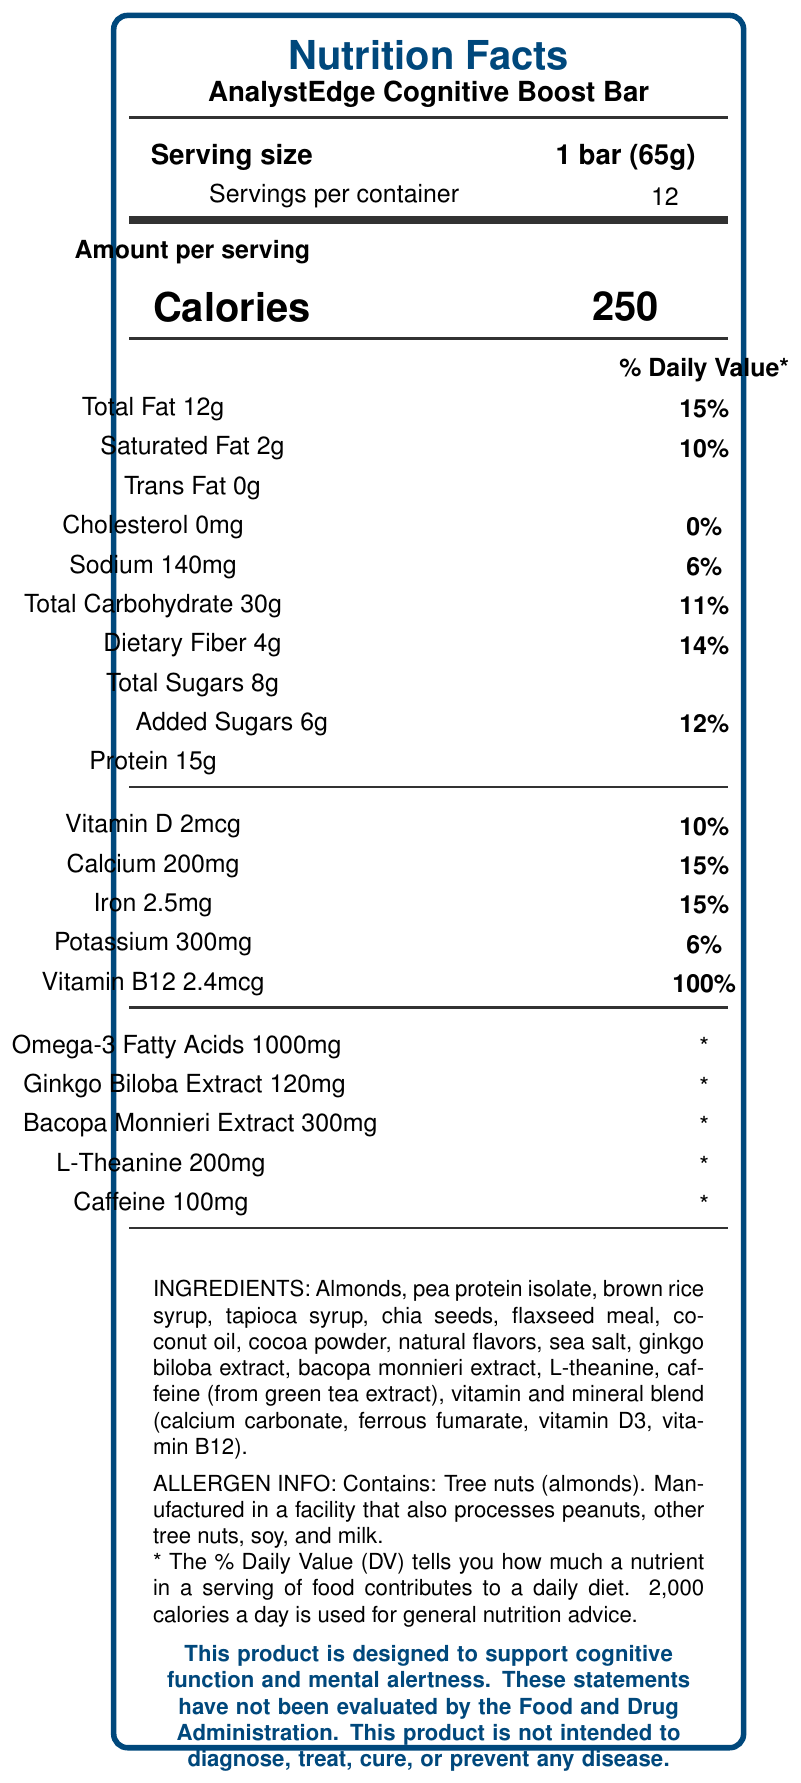What is the serving size of the AnalystEdge Cognitive Boost Bar? The serving size is mentioned directly under the "Serving size" section as 1 bar weighing 65 grams.
Answer: 1 bar (65g) How many servings are there per container? The number of servings per container is listed right under the "Serving size" and next to the label "Servings per container."
Answer: 12 How many calories are in one serving of the AnalystEdge Cognitive Boost Bar? Calories per serving are listed prominently in the middle of the label, indicating 250 calories per bar.
Answer: 250 What are the total carbohydrates in one bar? The total carbohydrate content is listed in the nutrition facts section, under the macronutrients breakdown, as 30 grams.
Answer: 30g How much protein does one bar contain? Under the nutrition facts section, the protein content per serving is listed as 15 grams.
Answer: 15g How much caffeine is included in one bar? A. 50mg B. 75mg C. 100mg D. 150mg The caffeine amount is listed under the cognitive enhancement ingredients and specified as 100mg.
Answer: C. 100mg What percentage of the daily value for Vitamin B12 does one bar provide? A. 50% B. 75% C. 100% D. 150% The daily value for Vitamin B12 is listed under the nutrition facts section and is given as 100%.
Answer: C. 100% True or False: The AnalystEdge Cognitive Boost Bar contains zero trans fat. The nutrition facts explicitly mention "Trans Fat 0g," indicating there is no trans fat.
Answer: True What are the claimed benefits of the AnalystEdge Cognitive Boost Bar according to the document? The bottom of the document states that the bar is designed to support cognitive function and mental alertness.
Answer: Support cognitive function and mental alertness List three special ingredients included in the AnalystEdge Cognitive Boost Bar that are meant to enhance cognitive function. These ingredients are listed under the section detailing cognitive enhancement ingredients.
Answer: Ginkgo biloba extract, Bacopa monnieri extract, and L-theanine Describe the entire document The document provides detailed nutritional information for the AnalystEdge Cognitive Boost Bar, including calories, macronutrients, and micronutrients per serving, specific cognitive-enhancing ingredients, allergen information, and general product details.
Answer: Nutrition facts label for AnalystEdge Cognitive Boost Bar detailing serving size, number of servings per container, calories, macronutrient and micronutrient content, specific cognitive-enhancing ingredients, and allergy information. What is the sodium content in one serving? The sodium content is listed in the nutrition facts under nutrients, and it is 140mg per serving.
Answer: 140mg Does the AnalystEdge Cognitive Boost Bar contain any tree nuts? The allergen information explicitly states that the bar contains tree nuts (almonds).
Answer: Yes Can you determine the manufacturing date of the AnalystEdge Cognitive Boost Bar? The document does not provide any details about the manufacturing date.
Answer: Not enough information What are the primary lipid sources in the energy bar? A. Palm oil and soybean oil B. Coconut oil and flaxseed meal C. Butter and canola oil The ingredients list includes coconut oil and flaxseed meal, which serve as primary lipid sources.
Answer: B. Coconut oil and flaxseed meal 